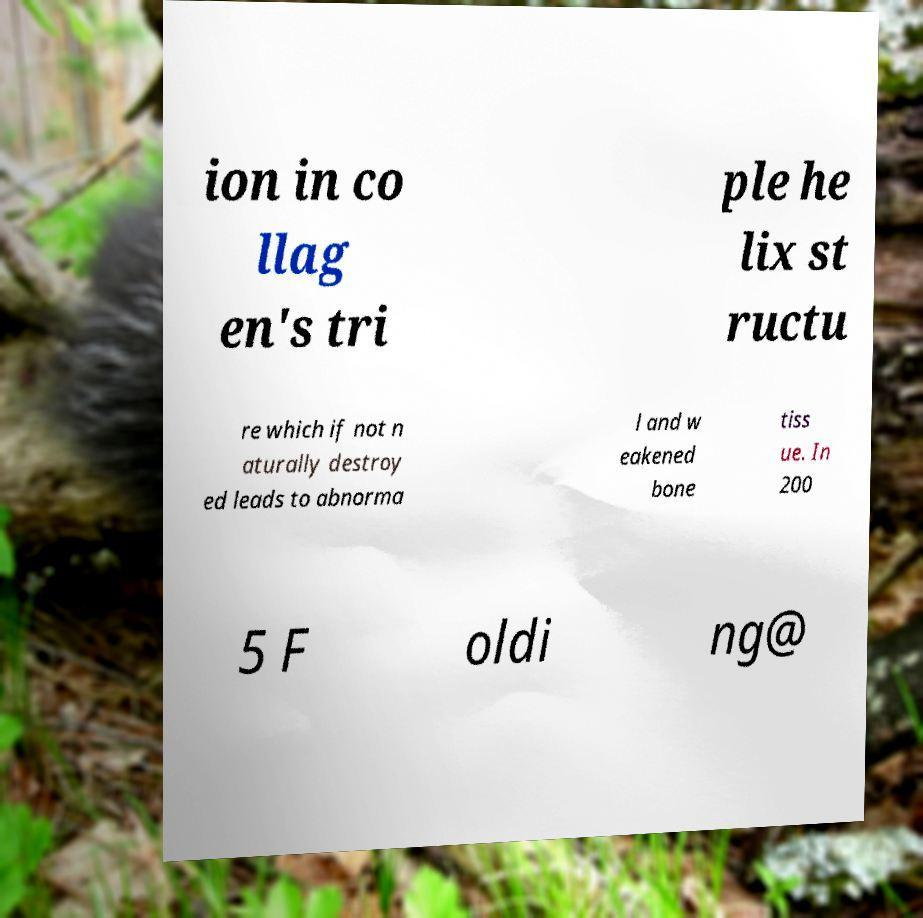What messages or text are displayed in this image? I need them in a readable, typed format. ion in co llag en's tri ple he lix st ructu re which if not n aturally destroy ed leads to abnorma l and w eakened bone tiss ue. In 200 5 F oldi ng@ 